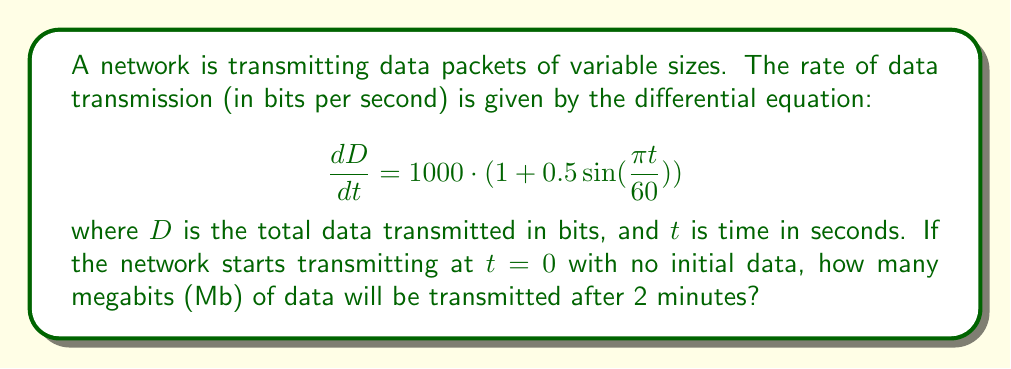Can you solve this math problem? To solve this problem, we need to integrate the given rate equation over the specified time interval. Let's break it down step by step:

1) The rate equation is:

   $$\frac{dD}{dt} = 1000 \cdot (1 + 0.5 \sin(\frac{\pi t}{60}))$$

2) To find the total data transmitted, we need to integrate both sides:

   $$\int_0^{120} dD = \int_0^{120} 1000 \cdot (1 + 0.5 \sin(\frac{\pi t}{60})) dt$$

3) Let's solve the right-hand side integral:

   $$1000 \int_0^{120} (1 + 0.5 \sin(\frac{\pi t}{60})) dt$$
   
   $$= 1000 \cdot [t - \frac{60}{\pi} \cdot 0.5 \cos(\frac{\pi t}{60})]_0^{120}$$

4) Evaluating the integral:

   $$= 1000 \cdot [(120 - \frac{60}{\pi} \cdot 0.5 \cos(2\pi)) - (0 - \frac{60}{\pi} \cdot 0.5 \cos(0))]$$
   
   $$= 1000 \cdot [120 - \frac{30}{\pi} \cos(2\pi) + \frac{30}{\pi}]$$
   
   $$= 1000 \cdot [120 + \frac{30}{\pi}]$$

5) Calculating the result:

   $$= 120000 + \frac{30000}{\pi} \approx 129549.30 \text{ bits}$$

6) Converting to megabits:

   $$129549.30 \text{ bits} \cdot \frac{1 \text{ Mb}}{1000000 \text{ bits}} \approx 0.12955 \text{ Mb}$$
Answer: Approximately 0.13 Mb (megabits) of data will be transmitted after 2 minutes. 